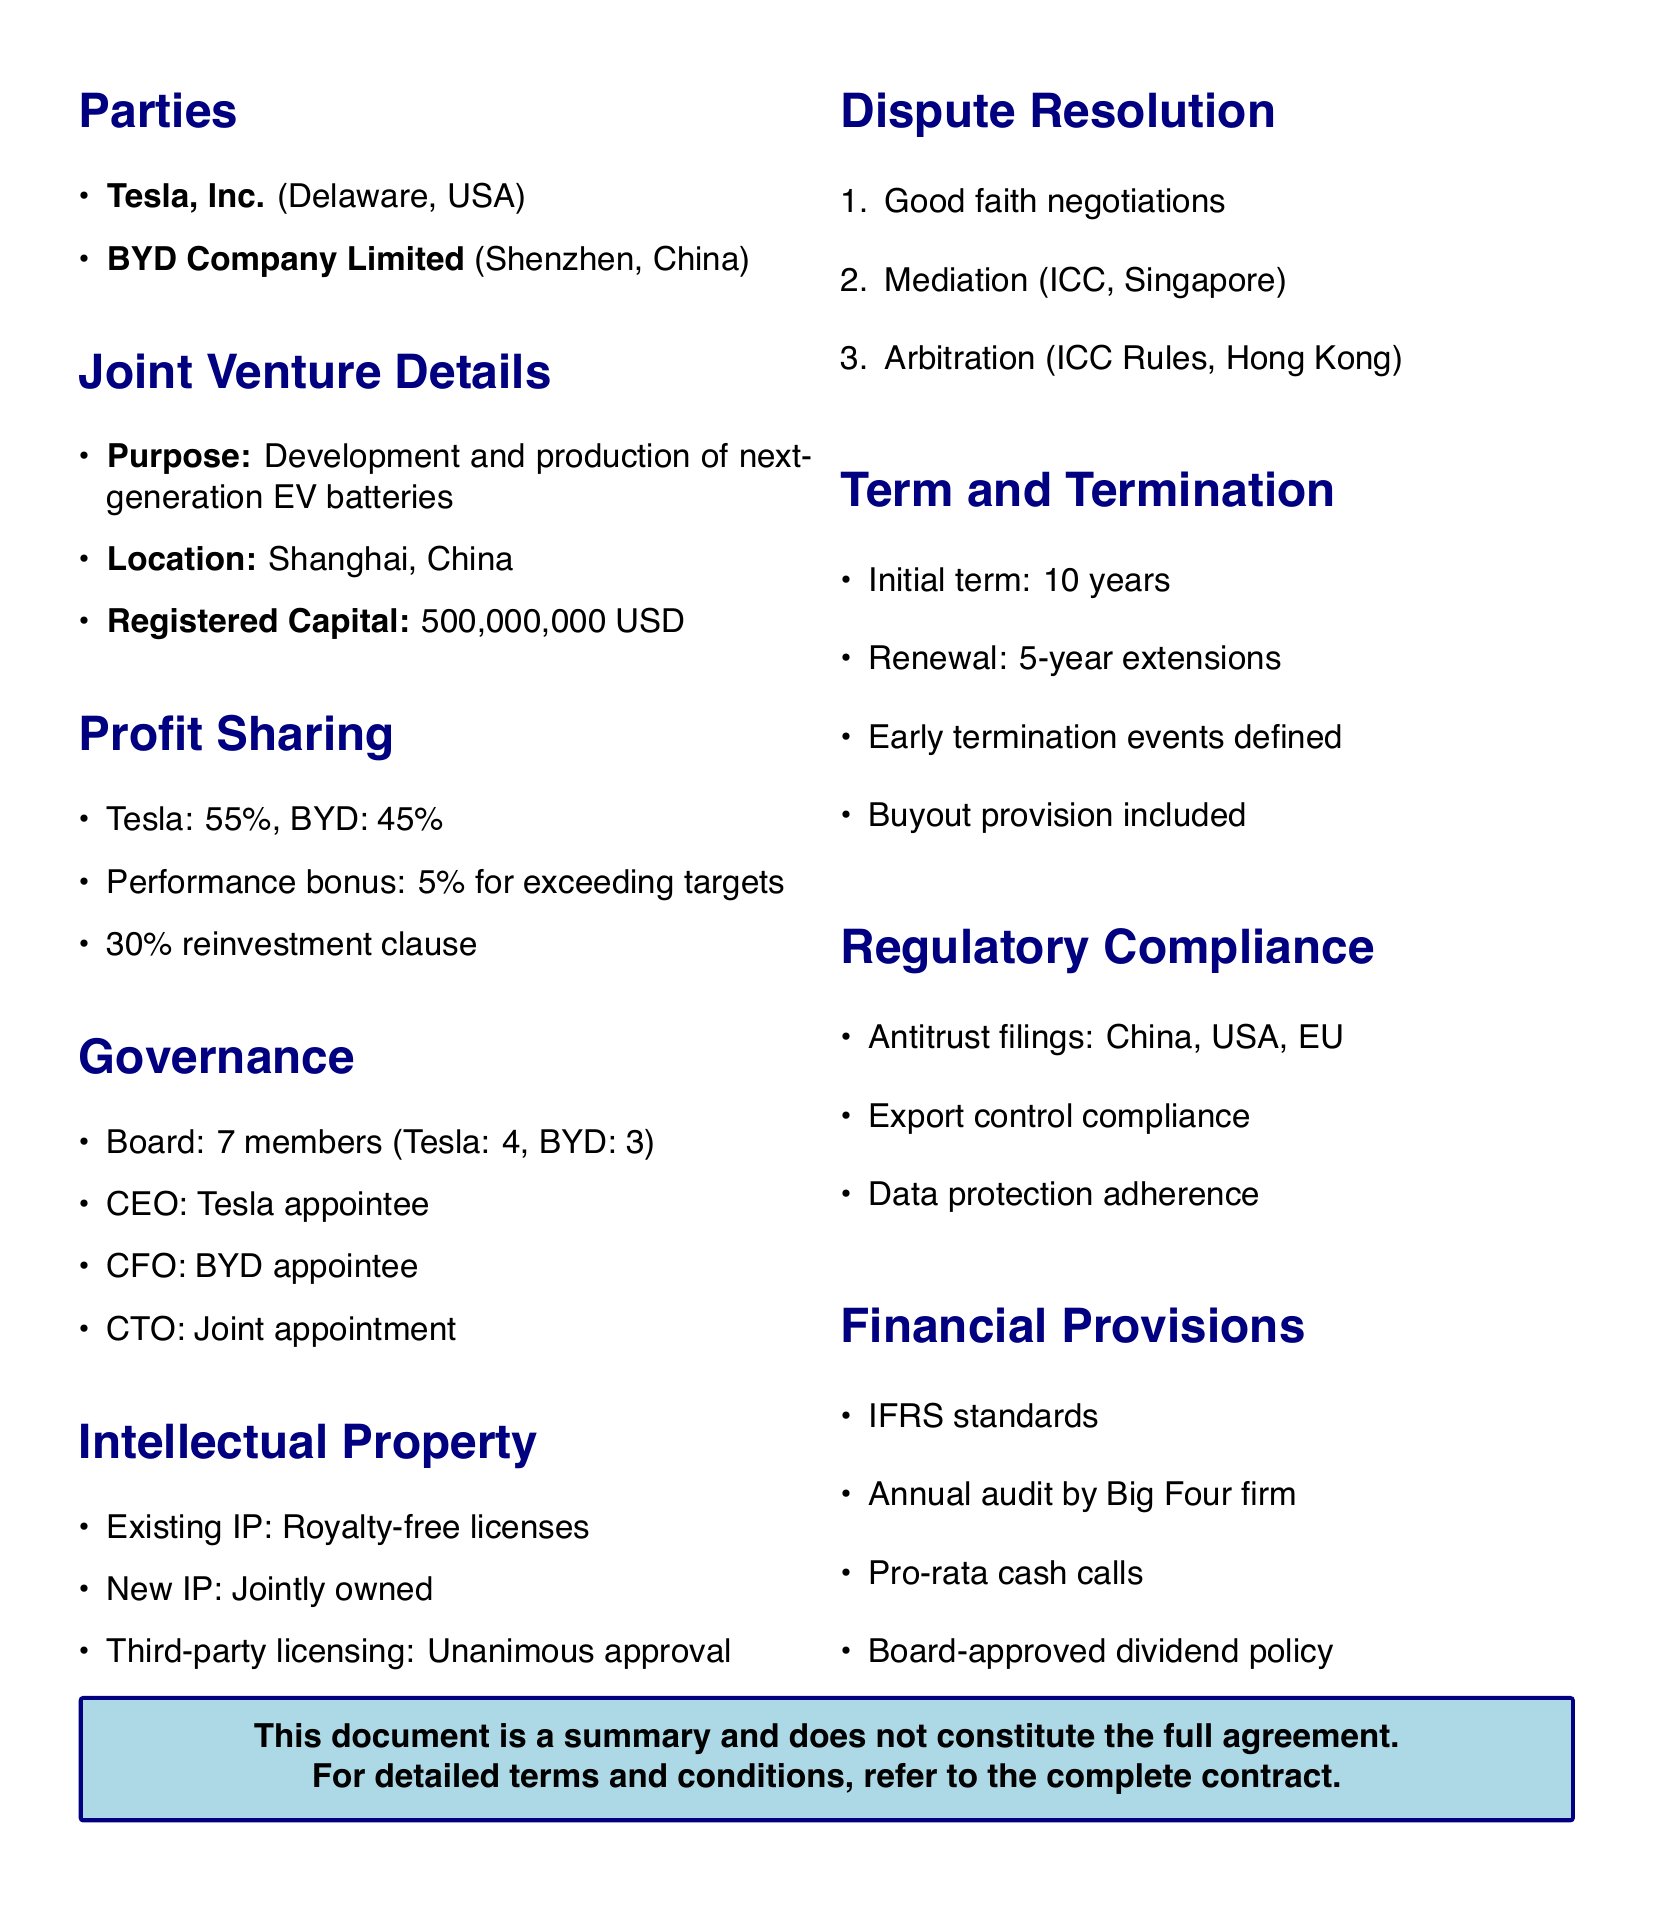What is the name of the joint venture? The joint venture is referred to as TeslaBYD Energy Solutions.
Answer: TeslaBYD Energy Solutions What percentage of profits does Tesla initially receive? The document specifies that Tesla receives 55% of the initial profit distribution.
Answer: 55% What is the registered capital of the joint venture? The registered capital amount is provided in the document as 500,000,000 USD.
Answer: 500,000,000 USD Where is the mediation for disputes to take place? The location of mediation is specified as Singapore in the dispute resolution section.
Answer: Singapore How long is the initial term of the joint venture? The initial term is clearly stated in the termination clauses as 10 years.
Answer: 10 years What is the bonus percentage for exceeding production targets? The document indicates there is an additional 5% profit share for exceeding annual production targets.
Answer: 5% What are the voting rights required for key strategic decisions? The governance section outlines that a supermajority of 75% is needed for these decisions.
Answer: 75% Who appoints the CEO of the joint venture? The document specifies that the CEO is appointed by Tesla.
Answer: Tesla What criteria can trigger an adjustment in profit sharing? The adjustment criteria include annual sales targets, R&D milestones, and patent contributions.
Answer: Annual sales targets, R&D milestones, patent contributions 